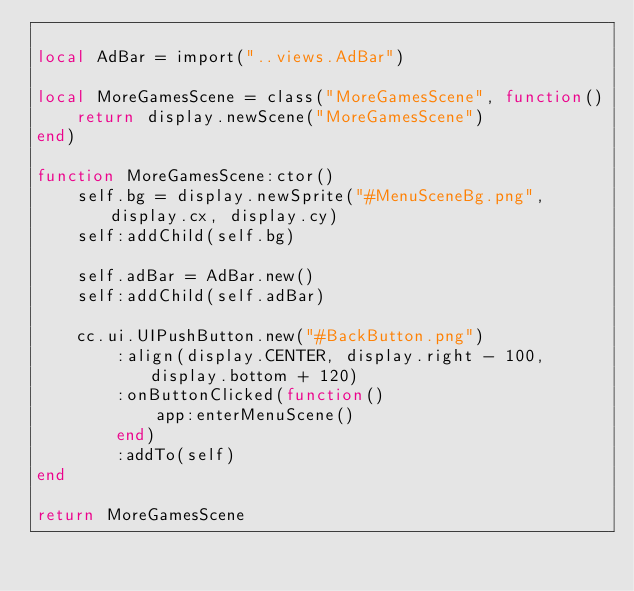<code> <loc_0><loc_0><loc_500><loc_500><_Lua_>
local AdBar = import("..views.AdBar")

local MoreGamesScene = class("MoreGamesScene", function()
    return display.newScene("MoreGamesScene")
end)

function MoreGamesScene:ctor()
    self.bg = display.newSprite("#MenuSceneBg.png", display.cx, display.cy)
    self:addChild(self.bg)

    self.adBar = AdBar.new()
    self:addChild(self.adBar)

    cc.ui.UIPushButton.new("#BackButton.png")
        :align(display.CENTER, display.right - 100, display.bottom + 120)
        :onButtonClicked(function()
            app:enterMenuScene()
        end)
        :addTo(self)
end

return MoreGamesScene
</code> 